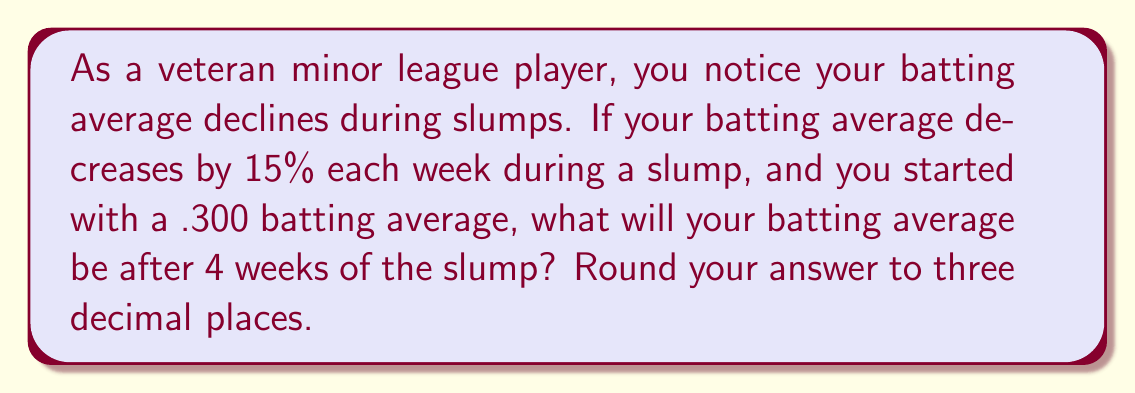Could you help me with this problem? Let's approach this step-by-step:

1) First, we need to identify the initial value and the decay rate:
   Initial batting average: 0.300
   Decay rate: 15% = 0.15 per week

2) In exponential decay, we multiply the previous value by (1 - decay rate) for each time period. In this case, we multiply by (1 - 0.15) = 0.85 each week.

3) The formula for exponential decay is:
   $$A = A_0 \cdot (1-r)^t$$
   Where:
   $A$ is the final value
   $A_0$ is the initial value
   $r$ is the decay rate
   $t$ is the number of time periods

4) Plugging in our values:
   $$A = 0.300 \cdot (0.85)^4$$

5) Now let's calculate:
   $$A = 0.300 \cdot 0.5220$$
   $$A = 0.1566$$

6) Rounding to three decimal places:
   $$A \approx 0.157$$

Therefore, after 4 weeks of the slump, the batting average will be approximately 0.157 or .157 in baseball notation.
Answer: .157 